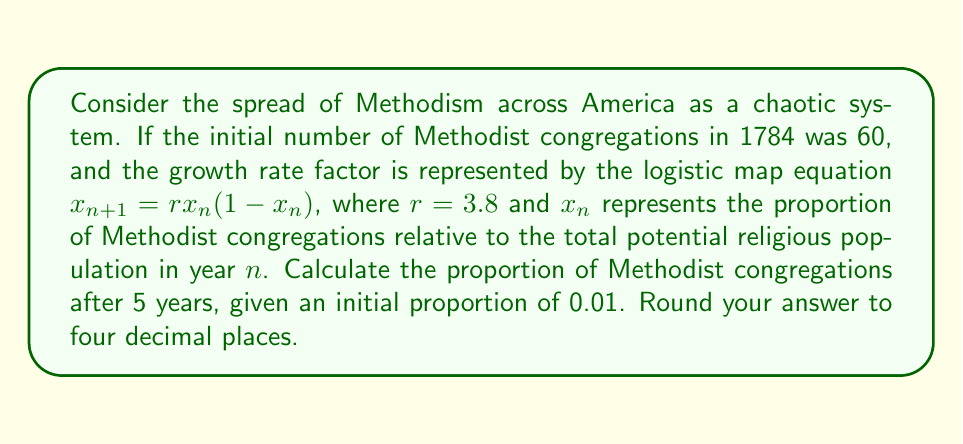Solve this math problem. To solve this problem, we'll use the logistic map equation iteratively for 5 years:

1) Initial proportion: $x_0 = 0.01$
2) Growth rate factor: $r = 3.8$
3) Equation: $x_{n+1} = rx_n(1-x_n)$

Let's calculate for each year:

Year 1: $x_1 = 3.8 * 0.01 * (1-0.01) = 0.03762$

Year 2: $x_2 = 3.8 * 0.03762 * (1-0.03762) = 0.13741$

Year 3: $x_3 = 3.8 * 0.13741 * (1-0.13741) = 0.45091$

Year 4: $x_4 = 3.8 * 0.45091 * (1-0.45091) = 0.94117$

Year 5: $x_5 = 3.8 * 0.94117 * (1-0.94117) = 0.21013$

Rounding to four decimal places: 0.2101
Answer: 0.2101 